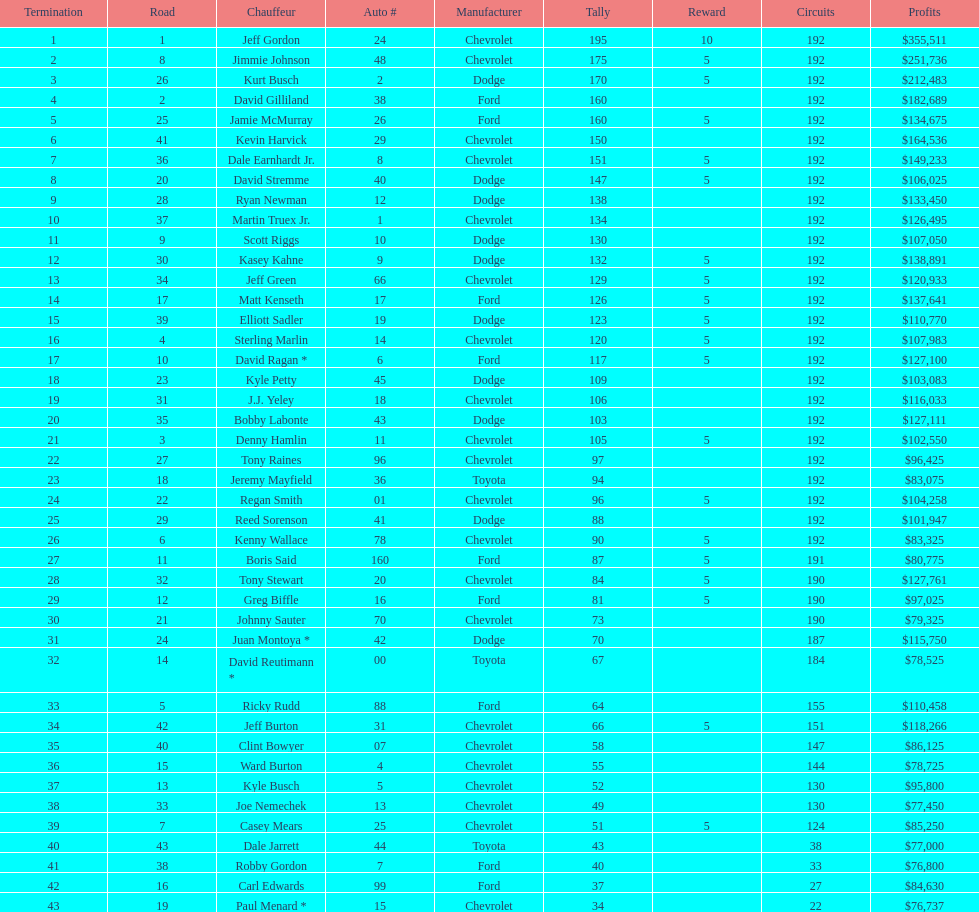What make did kurt busch drive? Dodge. 